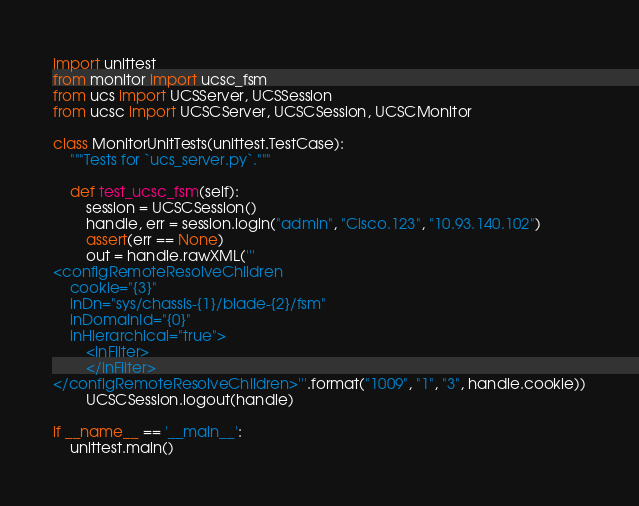<code> <loc_0><loc_0><loc_500><loc_500><_Python_>import unittest
from monitor import ucsc_fsm
from ucs import UCSServer, UCSSession
from ucsc import UCSCServer, UCSCSession, UCSCMonitor

class MonitorUnitTests(unittest.TestCase):
    """Tests for `ucs_server.py`."""

    def test_ucsc_fsm(self):
        session = UCSCSession()
        handle, err = session.login("admin", "Cisco.123", "10.93.140.102")
        assert(err == None)
        out = handle.rawXML('''
<configRemoteResolveChildren
    cookie="{3}"
    inDn="sys/chassis-{1}/blade-{2}/fsm"
    inDomainId="{0}"
    inHierarchical="true">
        <inFilter>
        </inFilter>
</configRemoteResolveChildren>'''.format("1009", "1", "3", handle.cookie))
        UCSCSession.logout(handle)
    
if __name__ == '__main__':
    unittest.main()
</code> 